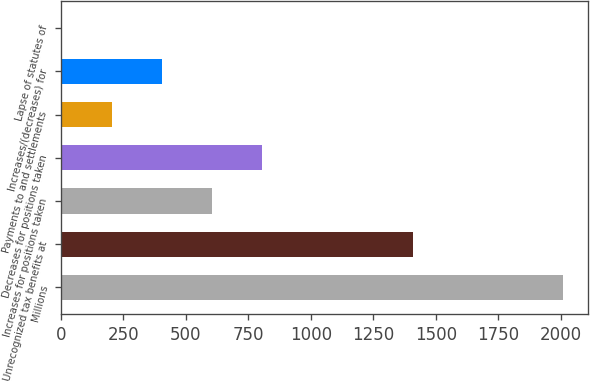<chart> <loc_0><loc_0><loc_500><loc_500><bar_chart><fcel>Millions<fcel>Unrecognized tax benefits at<fcel>Increases for positions taken<fcel>Decreases for positions taken<fcel>Payments to and settlements<fcel>Increases/(decreases) for<fcel>Lapse of statutes of<nl><fcel>2010<fcel>1407.9<fcel>605.1<fcel>805.8<fcel>203.7<fcel>404.4<fcel>3<nl></chart> 